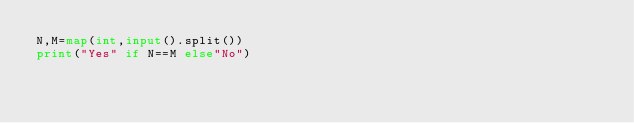Convert code to text. <code><loc_0><loc_0><loc_500><loc_500><_Python_>N,M=map(int,input().split())
print("Yes" if N==M else"No")</code> 